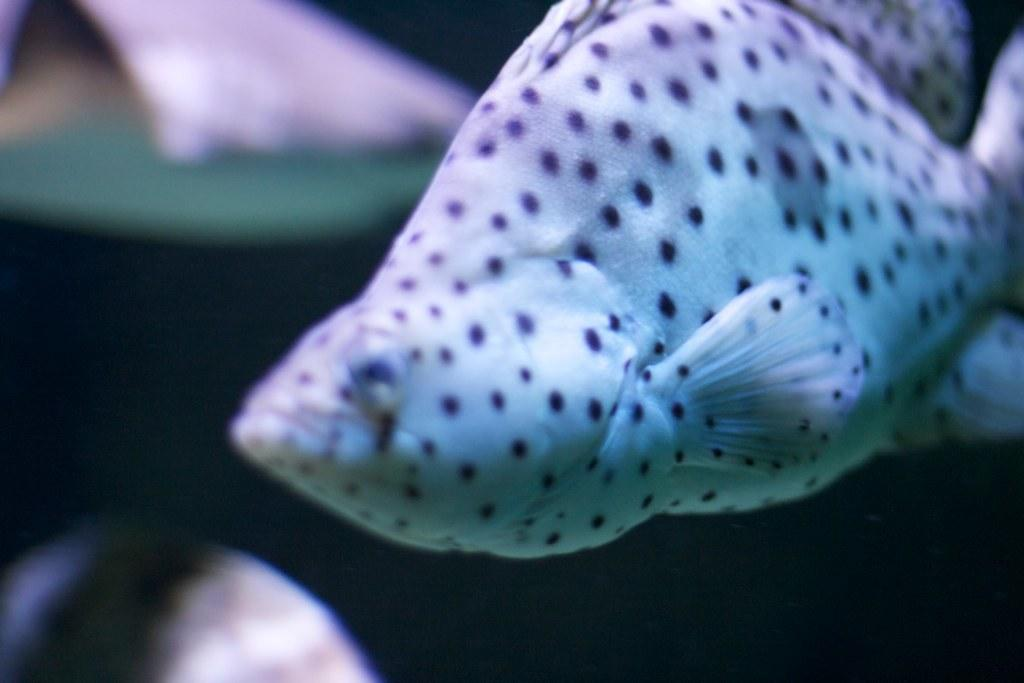What is the main subject in the foreground of the image? There is a fish in the foreground of the image. Can you describe the background of the image? There are two fishes in the background of the image. What language are the fishes speaking in the image? Fish do not have the ability to speak any language, so this question cannot be answered. 